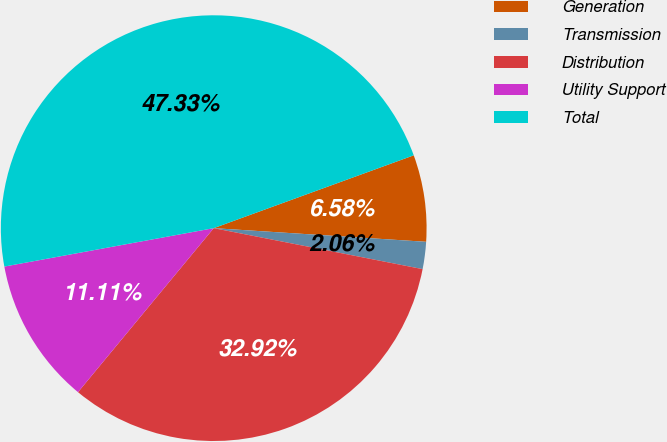<chart> <loc_0><loc_0><loc_500><loc_500><pie_chart><fcel>Generation<fcel>Transmission<fcel>Distribution<fcel>Utility Support<fcel>Total<nl><fcel>6.58%<fcel>2.06%<fcel>32.92%<fcel>11.11%<fcel>47.33%<nl></chart> 